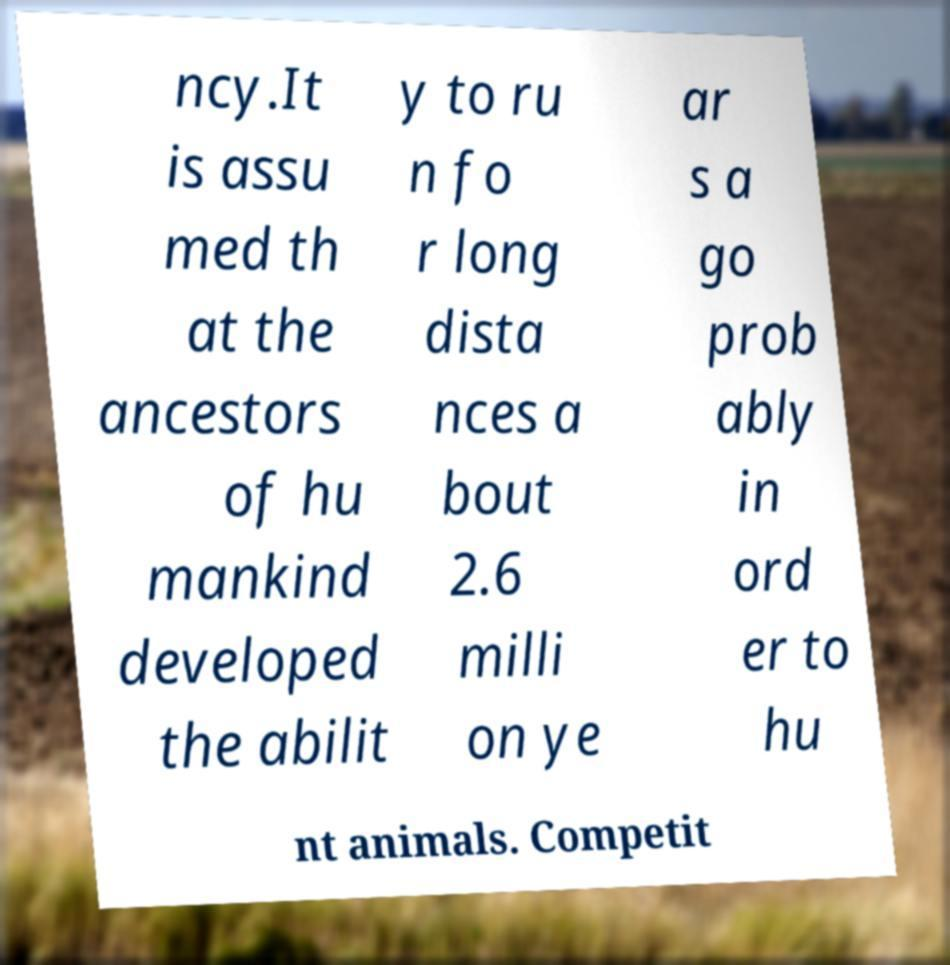Can you read and provide the text displayed in the image?This photo seems to have some interesting text. Can you extract and type it out for me? ncy.It is assu med th at the ancestors of hu mankind developed the abilit y to ru n fo r long dista nces a bout 2.6 milli on ye ar s a go prob ably in ord er to hu nt animals. Competit 